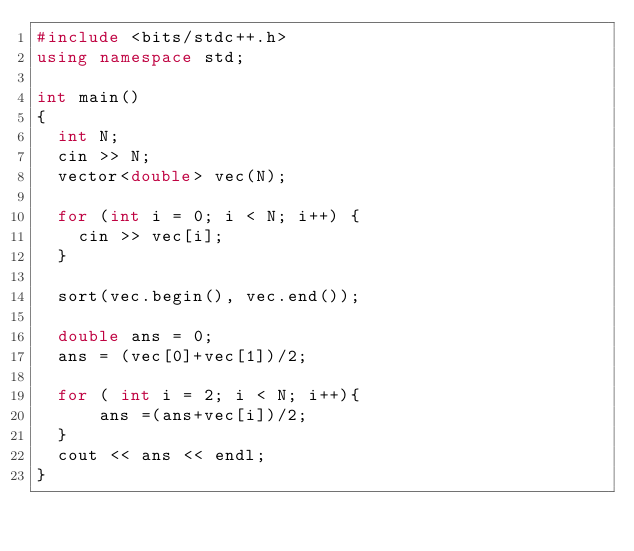Convert code to text. <code><loc_0><loc_0><loc_500><loc_500><_C++_>#include <bits/stdc++.h>
using namespace std;
 
int main()
{
  int N;
  cin >> N;
  vector<double> vec(N);

  for (int i = 0; i < N; i++) {
    cin >> vec[i];
  }
  
  sort(vec.begin(), vec.end());
  
  double ans = 0;
  ans = (vec[0]+vec[1])/2;
  
  for ( int i = 2; i < N; i++){
      ans =(ans+vec[i])/2;
  }
  cout << ans << endl;
}
    </code> 